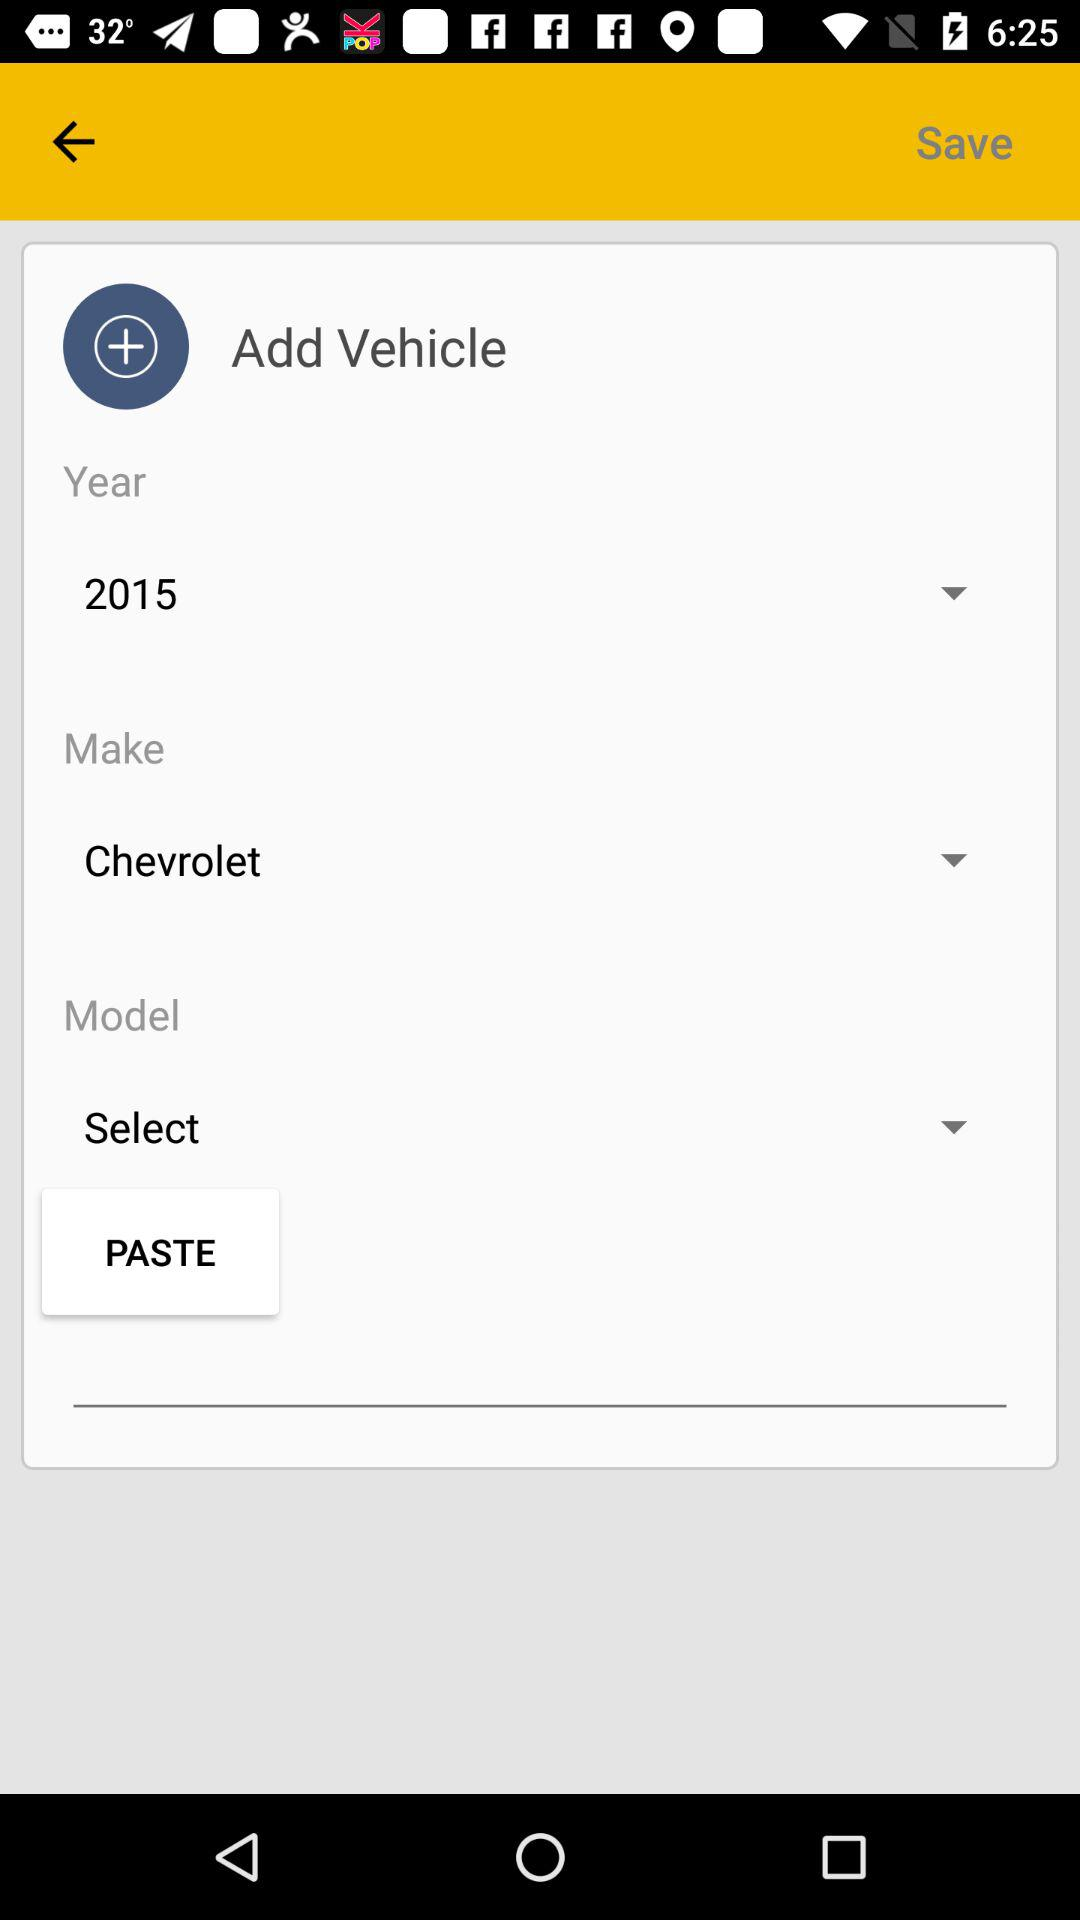Which model was selected?
When the provided information is insufficient, respond with <no answer>. <no answer> 